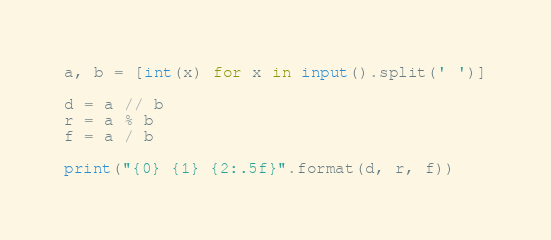Convert code to text. <code><loc_0><loc_0><loc_500><loc_500><_Python_>a, b = [int(x) for x in input().split(' ')]
 
d = a // b
r = a % b
f = a / b
 
print("{0} {1} {2:.5f}".format(d, r, f))</code> 